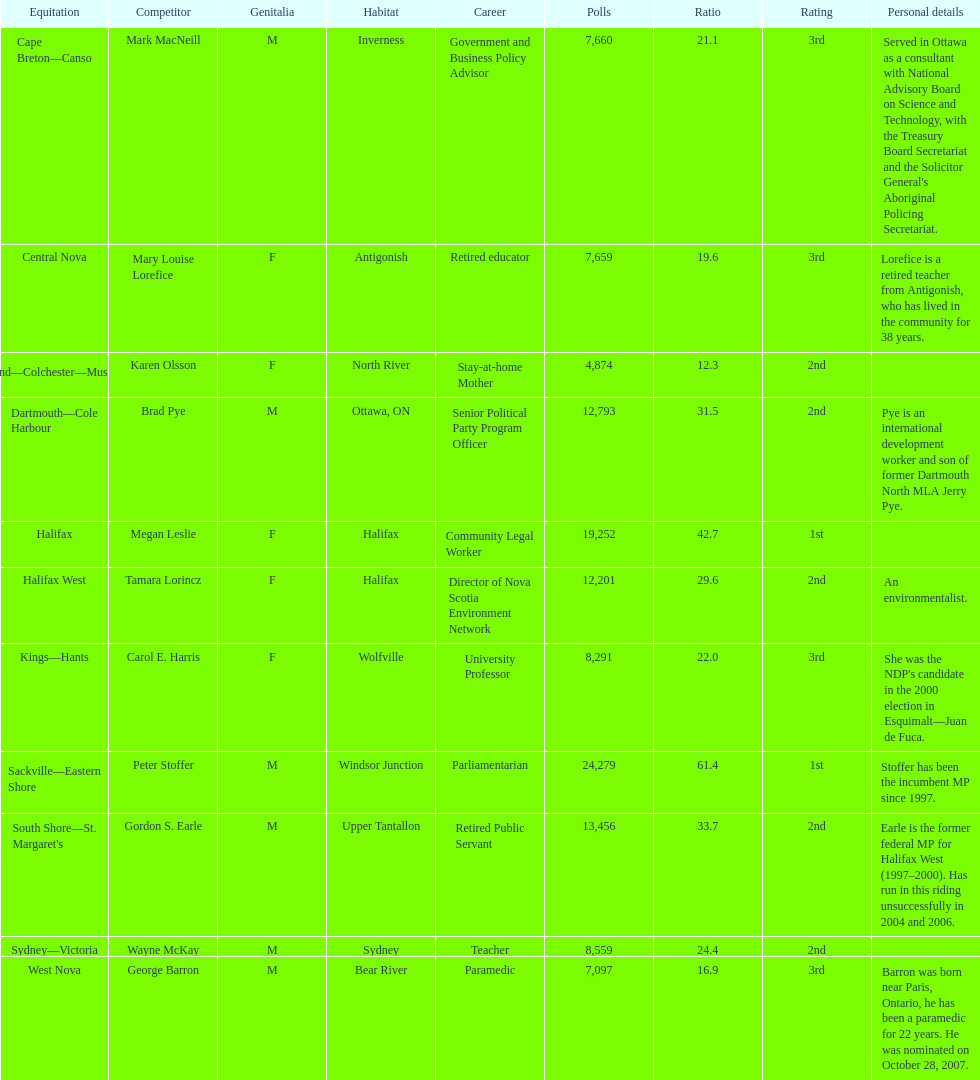Could you parse the entire table? {'header': ['Equitation', 'Competitor', 'Genitalia', 'Habitat', 'Career', 'Polls', 'Ratio', 'Rating', 'Personal details'], 'rows': [['Cape Breton—Canso', 'Mark MacNeill', 'M', 'Inverness', 'Government and Business Policy Advisor', '7,660', '21.1', '3rd', "Served in Ottawa as a consultant with National Advisory Board on Science and Technology, with the Treasury Board Secretariat and the Solicitor General's Aboriginal Policing Secretariat."], ['Central Nova', 'Mary Louise Lorefice', 'F', 'Antigonish', 'Retired educator', '7,659', '19.6', '3rd', 'Lorefice is a retired teacher from Antigonish, who has lived in the community for 38 years.'], ['Cumberland—Colchester—Musquodoboit Valley', 'Karen Olsson', 'F', 'North River', 'Stay-at-home Mother', '4,874', '12.3', '2nd', ''], ['Dartmouth—Cole Harbour', 'Brad Pye', 'M', 'Ottawa, ON', 'Senior Political Party Program Officer', '12,793', '31.5', '2nd', 'Pye is an international development worker and son of former Dartmouth North MLA Jerry Pye.'], ['Halifax', 'Megan Leslie', 'F', 'Halifax', 'Community Legal Worker', '19,252', '42.7', '1st', ''], ['Halifax West', 'Tamara Lorincz', 'F', 'Halifax', 'Director of Nova Scotia Environment Network', '12,201', '29.6', '2nd', 'An environmentalist.'], ['Kings—Hants', 'Carol E. Harris', 'F', 'Wolfville', 'University Professor', '8,291', '22.0', '3rd', "She was the NDP's candidate in the 2000 election in Esquimalt—Juan de Fuca."], ['Sackville—Eastern Shore', 'Peter Stoffer', 'M', 'Windsor Junction', 'Parliamentarian', '24,279', '61.4', '1st', 'Stoffer has been the incumbent MP since 1997.'], ["South Shore—St. Margaret's", 'Gordon S. Earle', 'M', 'Upper Tantallon', 'Retired Public Servant', '13,456', '33.7', '2nd', 'Earle is the former federal MP for Halifax West (1997–2000). Has run in this riding unsuccessfully in 2004 and 2006.'], ['Sydney—Victoria', 'Wayne McKay', 'M', 'Sydney', 'Teacher', '8,559', '24.4', '2nd', ''], ['West Nova', 'George Barron', 'M', 'Bear River', 'Paramedic', '7,097', '16.9', '3rd', 'Barron was born near Paris, Ontario, he has been a paramedic for 22 years. He was nominated on October 28, 2007.']]} Who got a larger number of votes, macneill or olsson? Mark MacNeill. 